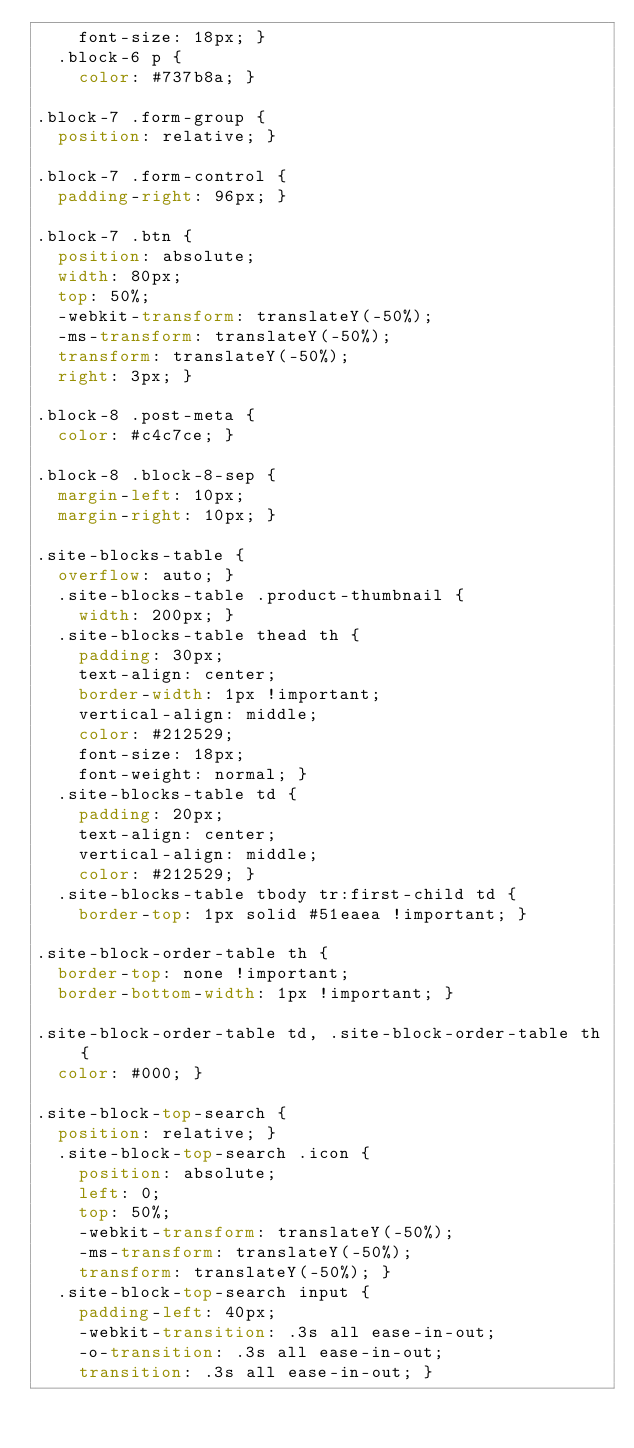<code> <loc_0><loc_0><loc_500><loc_500><_CSS_>    font-size: 18px; }
  .block-6 p {
    color: #737b8a; }

.block-7 .form-group {
  position: relative; }

.block-7 .form-control {
  padding-right: 96px; }

.block-7 .btn {
  position: absolute;
  width: 80px;
  top: 50%;
  -webkit-transform: translateY(-50%);
  -ms-transform: translateY(-50%);
  transform: translateY(-50%);
  right: 3px; }

.block-8 .post-meta {
  color: #c4c7ce; }

.block-8 .block-8-sep {
  margin-left: 10px;
  margin-right: 10px; }

.site-blocks-table {
  overflow: auto; }
  .site-blocks-table .product-thumbnail {
    width: 200px; }
  .site-blocks-table thead th {
    padding: 30px;
    text-align: center;
    border-width: 1px !important;
    vertical-align: middle;
    color: #212529;
    font-size: 18px;
    font-weight: normal; }
  .site-blocks-table td {
    padding: 20px;
    text-align: center;
    vertical-align: middle;
    color: #212529; }
  .site-blocks-table tbody tr:first-child td {
    border-top: 1px solid #51eaea !important; }

.site-block-order-table th {
  border-top: none !important;
  border-bottom-width: 1px !important; }

.site-block-order-table td, .site-block-order-table th {
  color: #000; }

.site-block-top-search {
  position: relative; }
  .site-block-top-search .icon {
    position: absolute;
    left: 0;
    top: 50%;
    -webkit-transform: translateY(-50%);
    -ms-transform: translateY(-50%);
    transform: translateY(-50%); }
  .site-block-top-search input {
    padding-left: 40px;
    -webkit-transition: .3s all ease-in-out;
    -o-transition: .3s all ease-in-out;
    transition: .3s all ease-in-out; }</code> 